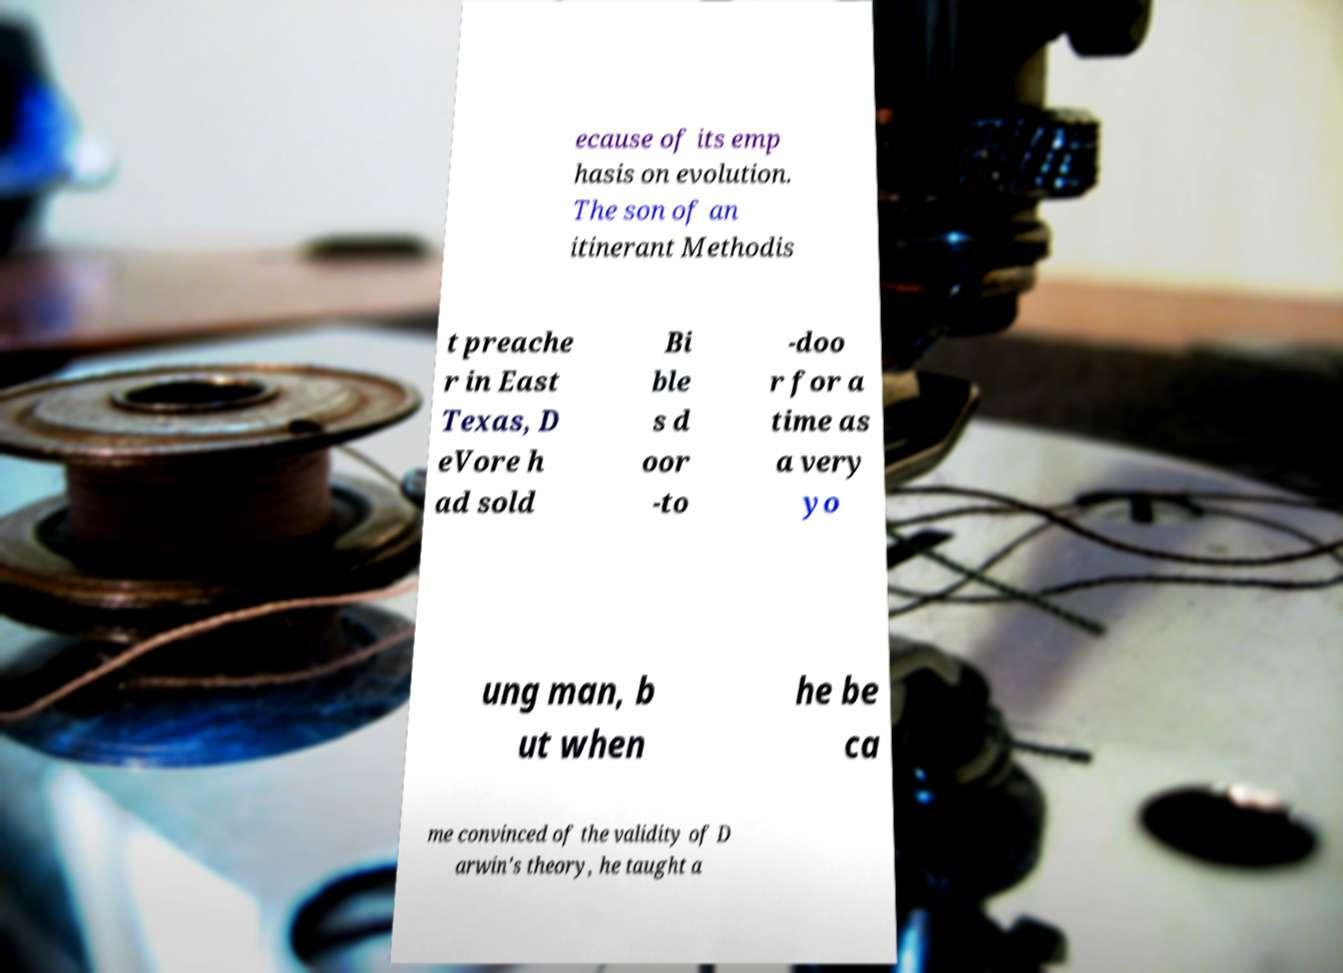What messages or text are displayed in this image? I need them in a readable, typed format. ecause of its emp hasis on evolution. The son of an itinerant Methodis t preache r in East Texas, D eVore h ad sold Bi ble s d oor -to -doo r for a time as a very yo ung man, b ut when he be ca me convinced of the validity of D arwin's theory, he taught a 